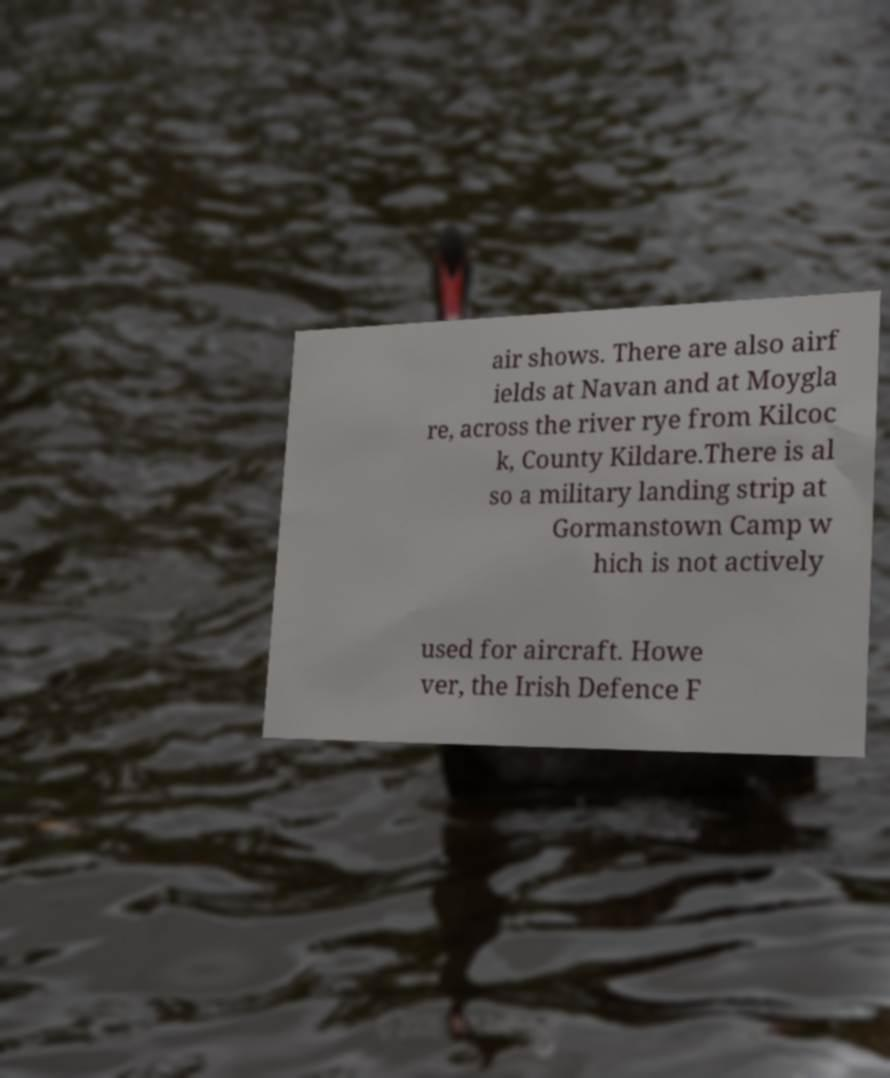I need the written content from this picture converted into text. Can you do that? air shows. There are also airf ields at Navan and at Moygla re, across the river rye from Kilcoc k, County Kildare.There is al so a military landing strip at Gormanstown Camp w hich is not actively used for aircraft. Howe ver, the Irish Defence F 